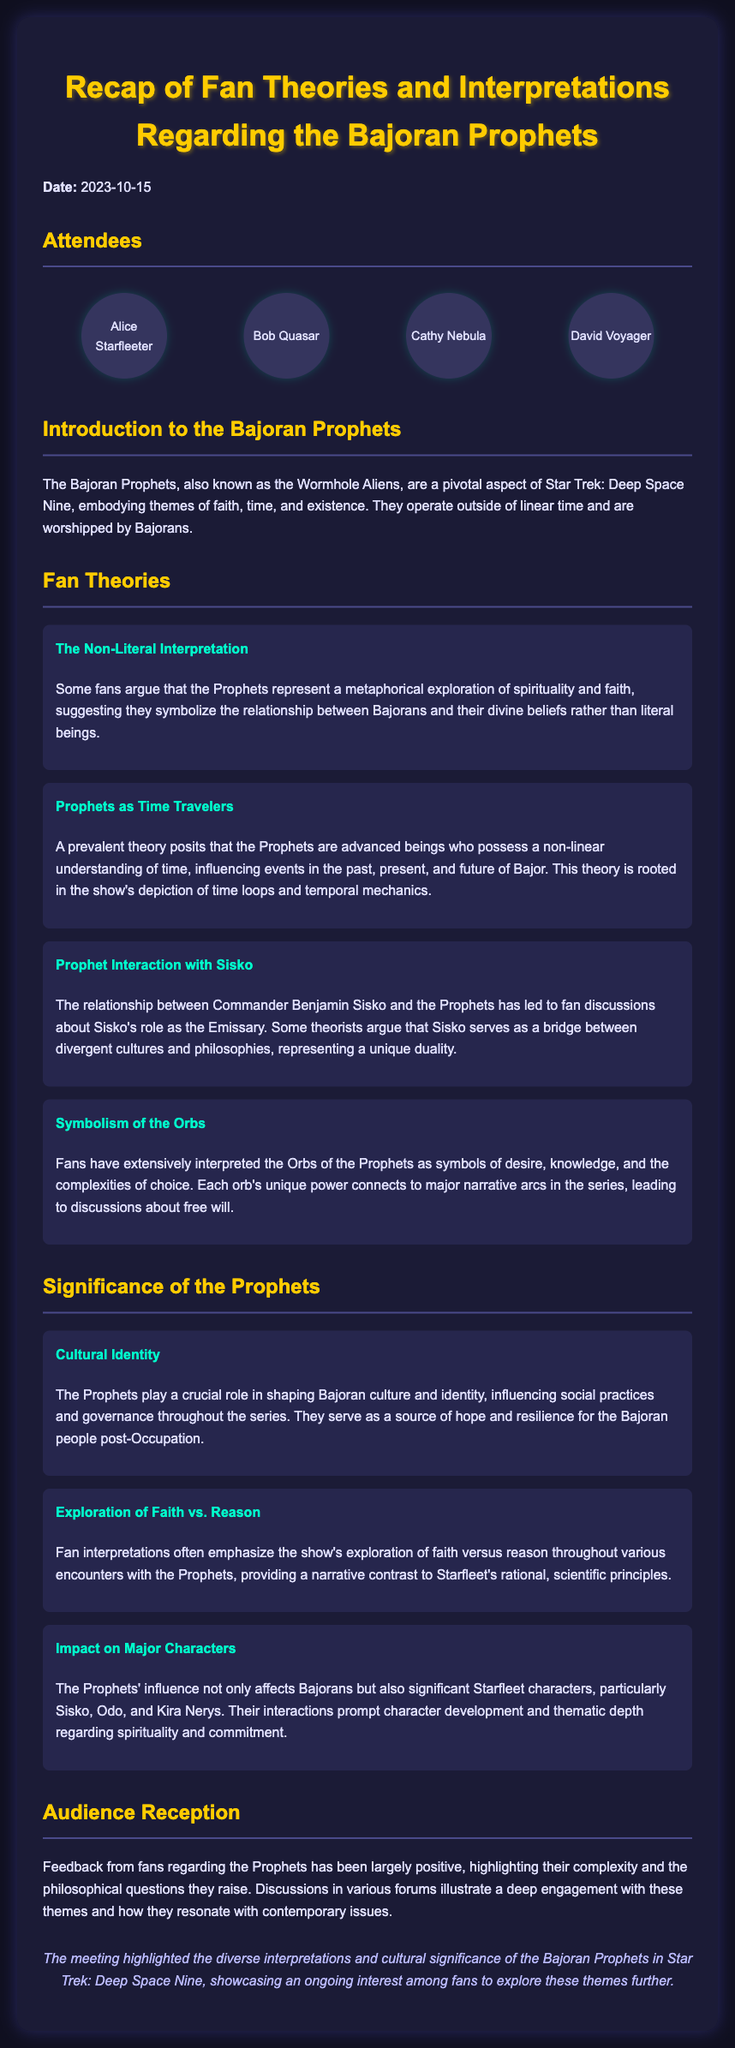what is the date of the meeting? The date of the meeting is specified in the introduction section of the document.
Answer: 2023-10-15 how many attendees were present? The number of attendees is listed in the attendees section of the document, showing four individual names.
Answer: 4 who is considered as the Emissary in relation to the Prophets? The document discusses a unique relationship with Commander Benjamin Sisko in the context of the Prophets.
Answer: Benjamin Sisko what is one interpretation of the Orbs? The document provides insights into various fan theories regarding the Orbs and their meanings.
Answer: Symbols of desire, knowledge, and the complexities of choice which character did the Prophets influence significantly? Significant Starfleet characters affected by the Prophets are mentioned in the significance section of the document.
Answer: Sisko, Odo, Kira Nerys what is the primary theme examined in the document? The overarching theme discussed in the meeting minutes relates to the Bajoran Prophets and their interpretations by fans.
Answer: Bajoran Prophets what is one aspect of the Bajoran culture influenced by the Prophets? The significance section outlines how the Prophets play a role in shaping Bajoran culture and identity.
Answer: Cultural Identity how is audience reception towards the Prophets described? The document summarizes feedback on the portrayal and themes regarding the Prophets, indicating the level of engagement among fans.
Answer: Largely positive 